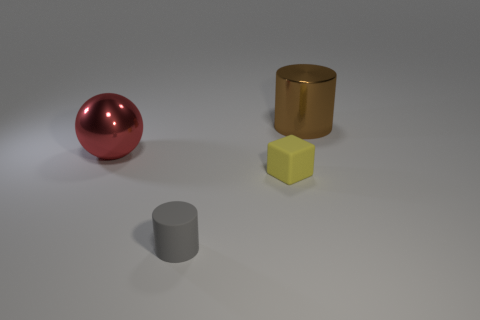Are there any other small objects that have the same shape as the yellow rubber object?
Offer a very short reply. No. What is the shape of the brown shiny thing that is the same size as the metal ball?
Offer a terse response. Cylinder. How many big metallic things are the same color as the large sphere?
Your answer should be very brief. 0. There is a metal thing that is on the right side of the red metallic ball; how big is it?
Give a very brief answer. Large. What number of balls are the same size as the red shiny object?
Keep it short and to the point. 0. What is the color of the big cylinder that is made of the same material as the ball?
Give a very brief answer. Brown. Is the number of tiny yellow rubber things that are behind the yellow matte cube less than the number of small gray cylinders?
Your answer should be very brief. Yes. What is the shape of the red object that is the same material as the large brown object?
Ensure brevity in your answer.  Sphere. How many metallic objects are small gray cylinders or tiny brown cylinders?
Keep it short and to the point. 0. Is the number of yellow matte blocks that are to the left of the gray object the same as the number of tiny blue metallic blocks?
Ensure brevity in your answer.  Yes. 